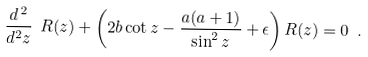Convert formula to latex. <formula><loc_0><loc_0><loc_500><loc_500>\frac { d ^ { \, 2 } } { d ^ { 2 } z } \ R ( z ) + \left ( 2 b \cot z - \frac { a ( a + 1 ) } { \sin ^ { 2 } z } + \epsilon \right ) R ( z ) = 0 \ .</formula> 